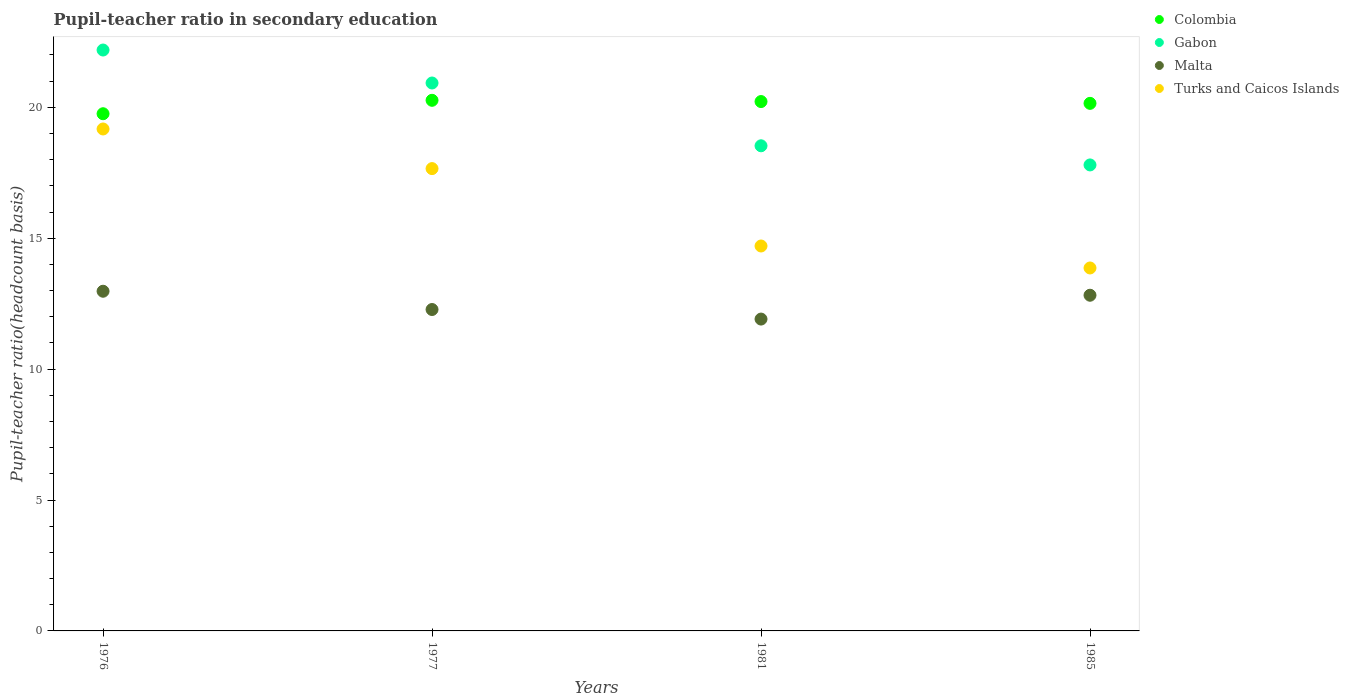How many different coloured dotlines are there?
Offer a very short reply. 4. What is the pupil-teacher ratio in secondary education in Malta in 1985?
Offer a very short reply. 12.82. Across all years, what is the maximum pupil-teacher ratio in secondary education in Turks and Caicos Islands?
Provide a short and direct response. 19.17. Across all years, what is the minimum pupil-teacher ratio in secondary education in Turks and Caicos Islands?
Your answer should be very brief. 13.86. In which year was the pupil-teacher ratio in secondary education in Turks and Caicos Islands maximum?
Offer a terse response. 1976. In which year was the pupil-teacher ratio in secondary education in Colombia minimum?
Keep it short and to the point. 1976. What is the total pupil-teacher ratio in secondary education in Malta in the graph?
Offer a very short reply. 49.98. What is the difference between the pupil-teacher ratio in secondary education in Turks and Caicos Islands in 1976 and that in 1981?
Your answer should be compact. 4.47. What is the difference between the pupil-teacher ratio in secondary education in Gabon in 1976 and the pupil-teacher ratio in secondary education in Malta in 1977?
Provide a succinct answer. 9.91. What is the average pupil-teacher ratio in secondary education in Malta per year?
Your answer should be very brief. 12.5. In the year 1976, what is the difference between the pupil-teacher ratio in secondary education in Turks and Caicos Islands and pupil-teacher ratio in secondary education in Gabon?
Your response must be concise. -3.02. What is the ratio of the pupil-teacher ratio in secondary education in Colombia in 1976 to that in 1985?
Your answer should be compact. 0.98. What is the difference between the highest and the second highest pupil-teacher ratio in secondary education in Gabon?
Make the answer very short. 1.26. What is the difference between the highest and the lowest pupil-teacher ratio in secondary education in Malta?
Your response must be concise. 1.06. In how many years, is the pupil-teacher ratio in secondary education in Turks and Caicos Islands greater than the average pupil-teacher ratio in secondary education in Turks and Caicos Islands taken over all years?
Offer a terse response. 2. Is the sum of the pupil-teacher ratio in secondary education in Malta in 1976 and 1981 greater than the maximum pupil-teacher ratio in secondary education in Turks and Caicos Islands across all years?
Offer a very short reply. Yes. Is it the case that in every year, the sum of the pupil-teacher ratio in secondary education in Turks and Caicos Islands and pupil-teacher ratio in secondary education in Malta  is greater than the pupil-teacher ratio in secondary education in Gabon?
Your answer should be very brief. Yes. Does the pupil-teacher ratio in secondary education in Turks and Caicos Islands monotonically increase over the years?
Your answer should be very brief. No. What is the difference between two consecutive major ticks on the Y-axis?
Provide a succinct answer. 5. Are the values on the major ticks of Y-axis written in scientific E-notation?
Provide a succinct answer. No. Does the graph contain any zero values?
Offer a terse response. No. Does the graph contain grids?
Offer a very short reply. No. Where does the legend appear in the graph?
Provide a short and direct response. Top right. How many legend labels are there?
Make the answer very short. 4. What is the title of the graph?
Keep it short and to the point. Pupil-teacher ratio in secondary education. What is the label or title of the X-axis?
Provide a short and direct response. Years. What is the label or title of the Y-axis?
Ensure brevity in your answer.  Pupil-teacher ratio(headcount basis). What is the Pupil-teacher ratio(headcount basis) of Colombia in 1976?
Your response must be concise. 19.75. What is the Pupil-teacher ratio(headcount basis) of Gabon in 1976?
Make the answer very short. 22.19. What is the Pupil-teacher ratio(headcount basis) of Malta in 1976?
Offer a very short reply. 12.97. What is the Pupil-teacher ratio(headcount basis) in Turks and Caicos Islands in 1976?
Keep it short and to the point. 19.17. What is the Pupil-teacher ratio(headcount basis) of Colombia in 1977?
Give a very brief answer. 20.27. What is the Pupil-teacher ratio(headcount basis) in Gabon in 1977?
Offer a very short reply. 20.93. What is the Pupil-teacher ratio(headcount basis) of Malta in 1977?
Your response must be concise. 12.28. What is the Pupil-teacher ratio(headcount basis) in Turks and Caicos Islands in 1977?
Your answer should be very brief. 17.66. What is the Pupil-teacher ratio(headcount basis) of Colombia in 1981?
Your response must be concise. 20.22. What is the Pupil-teacher ratio(headcount basis) of Gabon in 1981?
Keep it short and to the point. 18.53. What is the Pupil-teacher ratio(headcount basis) in Malta in 1981?
Your answer should be compact. 11.91. What is the Pupil-teacher ratio(headcount basis) in Turks and Caicos Islands in 1981?
Offer a very short reply. 14.7. What is the Pupil-teacher ratio(headcount basis) in Colombia in 1985?
Your answer should be compact. 20.15. What is the Pupil-teacher ratio(headcount basis) in Gabon in 1985?
Keep it short and to the point. 17.8. What is the Pupil-teacher ratio(headcount basis) of Malta in 1985?
Provide a short and direct response. 12.82. What is the Pupil-teacher ratio(headcount basis) of Turks and Caicos Islands in 1985?
Your answer should be very brief. 13.86. Across all years, what is the maximum Pupil-teacher ratio(headcount basis) in Colombia?
Your response must be concise. 20.27. Across all years, what is the maximum Pupil-teacher ratio(headcount basis) in Gabon?
Ensure brevity in your answer.  22.19. Across all years, what is the maximum Pupil-teacher ratio(headcount basis) of Malta?
Give a very brief answer. 12.97. Across all years, what is the maximum Pupil-teacher ratio(headcount basis) in Turks and Caicos Islands?
Offer a very short reply. 19.17. Across all years, what is the minimum Pupil-teacher ratio(headcount basis) of Colombia?
Your response must be concise. 19.75. Across all years, what is the minimum Pupil-teacher ratio(headcount basis) of Gabon?
Give a very brief answer. 17.8. Across all years, what is the minimum Pupil-teacher ratio(headcount basis) of Malta?
Offer a terse response. 11.91. Across all years, what is the minimum Pupil-teacher ratio(headcount basis) of Turks and Caicos Islands?
Your answer should be compact. 13.86. What is the total Pupil-teacher ratio(headcount basis) of Colombia in the graph?
Your answer should be very brief. 80.39. What is the total Pupil-teacher ratio(headcount basis) of Gabon in the graph?
Keep it short and to the point. 79.44. What is the total Pupil-teacher ratio(headcount basis) of Malta in the graph?
Offer a very short reply. 49.98. What is the total Pupil-teacher ratio(headcount basis) of Turks and Caicos Islands in the graph?
Give a very brief answer. 65.39. What is the difference between the Pupil-teacher ratio(headcount basis) in Colombia in 1976 and that in 1977?
Ensure brevity in your answer.  -0.51. What is the difference between the Pupil-teacher ratio(headcount basis) in Gabon in 1976 and that in 1977?
Offer a very short reply. 1.26. What is the difference between the Pupil-teacher ratio(headcount basis) of Malta in 1976 and that in 1977?
Provide a short and direct response. 0.7. What is the difference between the Pupil-teacher ratio(headcount basis) of Turks and Caicos Islands in 1976 and that in 1977?
Your answer should be very brief. 1.51. What is the difference between the Pupil-teacher ratio(headcount basis) in Colombia in 1976 and that in 1981?
Your answer should be compact. -0.47. What is the difference between the Pupil-teacher ratio(headcount basis) of Gabon in 1976 and that in 1981?
Provide a succinct answer. 3.66. What is the difference between the Pupil-teacher ratio(headcount basis) of Malta in 1976 and that in 1981?
Your answer should be compact. 1.06. What is the difference between the Pupil-teacher ratio(headcount basis) of Turks and Caicos Islands in 1976 and that in 1981?
Make the answer very short. 4.47. What is the difference between the Pupil-teacher ratio(headcount basis) of Colombia in 1976 and that in 1985?
Your answer should be compact. -0.4. What is the difference between the Pupil-teacher ratio(headcount basis) of Gabon in 1976 and that in 1985?
Give a very brief answer. 4.39. What is the difference between the Pupil-teacher ratio(headcount basis) of Malta in 1976 and that in 1985?
Your answer should be compact. 0.15. What is the difference between the Pupil-teacher ratio(headcount basis) in Turks and Caicos Islands in 1976 and that in 1985?
Offer a terse response. 5.31. What is the difference between the Pupil-teacher ratio(headcount basis) of Colombia in 1977 and that in 1981?
Your answer should be compact. 0.05. What is the difference between the Pupil-teacher ratio(headcount basis) of Gabon in 1977 and that in 1981?
Give a very brief answer. 2.4. What is the difference between the Pupil-teacher ratio(headcount basis) in Malta in 1977 and that in 1981?
Offer a terse response. 0.37. What is the difference between the Pupil-teacher ratio(headcount basis) of Turks and Caicos Islands in 1977 and that in 1981?
Give a very brief answer. 2.96. What is the difference between the Pupil-teacher ratio(headcount basis) in Colombia in 1977 and that in 1985?
Offer a terse response. 0.12. What is the difference between the Pupil-teacher ratio(headcount basis) in Gabon in 1977 and that in 1985?
Provide a succinct answer. 3.13. What is the difference between the Pupil-teacher ratio(headcount basis) of Malta in 1977 and that in 1985?
Offer a terse response. -0.55. What is the difference between the Pupil-teacher ratio(headcount basis) in Turks and Caicos Islands in 1977 and that in 1985?
Give a very brief answer. 3.8. What is the difference between the Pupil-teacher ratio(headcount basis) of Colombia in 1981 and that in 1985?
Keep it short and to the point. 0.07. What is the difference between the Pupil-teacher ratio(headcount basis) in Gabon in 1981 and that in 1985?
Your answer should be very brief. 0.73. What is the difference between the Pupil-teacher ratio(headcount basis) in Malta in 1981 and that in 1985?
Keep it short and to the point. -0.91. What is the difference between the Pupil-teacher ratio(headcount basis) of Turks and Caicos Islands in 1981 and that in 1985?
Your response must be concise. 0.84. What is the difference between the Pupil-teacher ratio(headcount basis) in Colombia in 1976 and the Pupil-teacher ratio(headcount basis) in Gabon in 1977?
Your response must be concise. -1.17. What is the difference between the Pupil-teacher ratio(headcount basis) of Colombia in 1976 and the Pupil-teacher ratio(headcount basis) of Malta in 1977?
Offer a terse response. 7.48. What is the difference between the Pupil-teacher ratio(headcount basis) in Colombia in 1976 and the Pupil-teacher ratio(headcount basis) in Turks and Caicos Islands in 1977?
Offer a very short reply. 2.1. What is the difference between the Pupil-teacher ratio(headcount basis) in Gabon in 1976 and the Pupil-teacher ratio(headcount basis) in Malta in 1977?
Your response must be concise. 9.91. What is the difference between the Pupil-teacher ratio(headcount basis) of Gabon in 1976 and the Pupil-teacher ratio(headcount basis) of Turks and Caicos Islands in 1977?
Ensure brevity in your answer.  4.53. What is the difference between the Pupil-teacher ratio(headcount basis) of Malta in 1976 and the Pupil-teacher ratio(headcount basis) of Turks and Caicos Islands in 1977?
Offer a terse response. -4.68. What is the difference between the Pupil-teacher ratio(headcount basis) in Colombia in 1976 and the Pupil-teacher ratio(headcount basis) in Gabon in 1981?
Make the answer very short. 1.22. What is the difference between the Pupil-teacher ratio(headcount basis) in Colombia in 1976 and the Pupil-teacher ratio(headcount basis) in Malta in 1981?
Your answer should be compact. 7.84. What is the difference between the Pupil-teacher ratio(headcount basis) in Colombia in 1976 and the Pupil-teacher ratio(headcount basis) in Turks and Caicos Islands in 1981?
Provide a short and direct response. 5.05. What is the difference between the Pupil-teacher ratio(headcount basis) in Gabon in 1976 and the Pupil-teacher ratio(headcount basis) in Malta in 1981?
Keep it short and to the point. 10.28. What is the difference between the Pupil-teacher ratio(headcount basis) in Gabon in 1976 and the Pupil-teacher ratio(headcount basis) in Turks and Caicos Islands in 1981?
Offer a terse response. 7.48. What is the difference between the Pupil-teacher ratio(headcount basis) in Malta in 1976 and the Pupil-teacher ratio(headcount basis) in Turks and Caicos Islands in 1981?
Your response must be concise. -1.73. What is the difference between the Pupil-teacher ratio(headcount basis) in Colombia in 1976 and the Pupil-teacher ratio(headcount basis) in Gabon in 1985?
Your answer should be very brief. 1.96. What is the difference between the Pupil-teacher ratio(headcount basis) in Colombia in 1976 and the Pupil-teacher ratio(headcount basis) in Malta in 1985?
Make the answer very short. 6.93. What is the difference between the Pupil-teacher ratio(headcount basis) of Colombia in 1976 and the Pupil-teacher ratio(headcount basis) of Turks and Caicos Islands in 1985?
Offer a very short reply. 5.89. What is the difference between the Pupil-teacher ratio(headcount basis) in Gabon in 1976 and the Pupil-teacher ratio(headcount basis) in Malta in 1985?
Offer a very short reply. 9.37. What is the difference between the Pupil-teacher ratio(headcount basis) in Gabon in 1976 and the Pupil-teacher ratio(headcount basis) in Turks and Caicos Islands in 1985?
Provide a short and direct response. 8.32. What is the difference between the Pupil-teacher ratio(headcount basis) of Malta in 1976 and the Pupil-teacher ratio(headcount basis) of Turks and Caicos Islands in 1985?
Keep it short and to the point. -0.89. What is the difference between the Pupil-teacher ratio(headcount basis) in Colombia in 1977 and the Pupil-teacher ratio(headcount basis) in Gabon in 1981?
Ensure brevity in your answer.  1.74. What is the difference between the Pupil-teacher ratio(headcount basis) in Colombia in 1977 and the Pupil-teacher ratio(headcount basis) in Malta in 1981?
Offer a terse response. 8.36. What is the difference between the Pupil-teacher ratio(headcount basis) of Colombia in 1977 and the Pupil-teacher ratio(headcount basis) of Turks and Caicos Islands in 1981?
Offer a terse response. 5.56. What is the difference between the Pupil-teacher ratio(headcount basis) of Gabon in 1977 and the Pupil-teacher ratio(headcount basis) of Malta in 1981?
Provide a succinct answer. 9.02. What is the difference between the Pupil-teacher ratio(headcount basis) in Gabon in 1977 and the Pupil-teacher ratio(headcount basis) in Turks and Caicos Islands in 1981?
Keep it short and to the point. 6.23. What is the difference between the Pupil-teacher ratio(headcount basis) in Malta in 1977 and the Pupil-teacher ratio(headcount basis) in Turks and Caicos Islands in 1981?
Provide a short and direct response. -2.43. What is the difference between the Pupil-teacher ratio(headcount basis) in Colombia in 1977 and the Pupil-teacher ratio(headcount basis) in Gabon in 1985?
Make the answer very short. 2.47. What is the difference between the Pupil-teacher ratio(headcount basis) of Colombia in 1977 and the Pupil-teacher ratio(headcount basis) of Malta in 1985?
Ensure brevity in your answer.  7.45. What is the difference between the Pupil-teacher ratio(headcount basis) in Colombia in 1977 and the Pupil-teacher ratio(headcount basis) in Turks and Caicos Islands in 1985?
Your answer should be compact. 6.4. What is the difference between the Pupil-teacher ratio(headcount basis) in Gabon in 1977 and the Pupil-teacher ratio(headcount basis) in Malta in 1985?
Your response must be concise. 8.11. What is the difference between the Pupil-teacher ratio(headcount basis) of Gabon in 1977 and the Pupil-teacher ratio(headcount basis) of Turks and Caicos Islands in 1985?
Provide a succinct answer. 7.07. What is the difference between the Pupil-teacher ratio(headcount basis) in Malta in 1977 and the Pupil-teacher ratio(headcount basis) in Turks and Caicos Islands in 1985?
Offer a terse response. -1.59. What is the difference between the Pupil-teacher ratio(headcount basis) in Colombia in 1981 and the Pupil-teacher ratio(headcount basis) in Gabon in 1985?
Keep it short and to the point. 2.42. What is the difference between the Pupil-teacher ratio(headcount basis) of Colombia in 1981 and the Pupil-teacher ratio(headcount basis) of Malta in 1985?
Ensure brevity in your answer.  7.4. What is the difference between the Pupil-teacher ratio(headcount basis) in Colombia in 1981 and the Pupil-teacher ratio(headcount basis) in Turks and Caicos Islands in 1985?
Your response must be concise. 6.36. What is the difference between the Pupil-teacher ratio(headcount basis) in Gabon in 1981 and the Pupil-teacher ratio(headcount basis) in Malta in 1985?
Your answer should be compact. 5.71. What is the difference between the Pupil-teacher ratio(headcount basis) of Gabon in 1981 and the Pupil-teacher ratio(headcount basis) of Turks and Caicos Islands in 1985?
Provide a short and direct response. 4.67. What is the difference between the Pupil-teacher ratio(headcount basis) in Malta in 1981 and the Pupil-teacher ratio(headcount basis) in Turks and Caicos Islands in 1985?
Offer a very short reply. -1.95. What is the average Pupil-teacher ratio(headcount basis) of Colombia per year?
Provide a succinct answer. 20.1. What is the average Pupil-teacher ratio(headcount basis) of Gabon per year?
Provide a succinct answer. 19.86. What is the average Pupil-teacher ratio(headcount basis) in Malta per year?
Offer a very short reply. 12.5. What is the average Pupil-teacher ratio(headcount basis) in Turks and Caicos Islands per year?
Provide a short and direct response. 16.35. In the year 1976, what is the difference between the Pupil-teacher ratio(headcount basis) of Colombia and Pupil-teacher ratio(headcount basis) of Gabon?
Your response must be concise. -2.43. In the year 1976, what is the difference between the Pupil-teacher ratio(headcount basis) in Colombia and Pupil-teacher ratio(headcount basis) in Malta?
Your response must be concise. 6.78. In the year 1976, what is the difference between the Pupil-teacher ratio(headcount basis) of Colombia and Pupil-teacher ratio(headcount basis) of Turks and Caicos Islands?
Make the answer very short. 0.58. In the year 1976, what is the difference between the Pupil-teacher ratio(headcount basis) in Gabon and Pupil-teacher ratio(headcount basis) in Malta?
Ensure brevity in your answer.  9.21. In the year 1976, what is the difference between the Pupil-teacher ratio(headcount basis) of Gabon and Pupil-teacher ratio(headcount basis) of Turks and Caicos Islands?
Make the answer very short. 3.02. In the year 1976, what is the difference between the Pupil-teacher ratio(headcount basis) of Malta and Pupil-teacher ratio(headcount basis) of Turks and Caicos Islands?
Your answer should be compact. -6.2. In the year 1977, what is the difference between the Pupil-teacher ratio(headcount basis) of Colombia and Pupil-teacher ratio(headcount basis) of Gabon?
Ensure brevity in your answer.  -0.66. In the year 1977, what is the difference between the Pupil-teacher ratio(headcount basis) in Colombia and Pupil-teacher ratio(headcount basis) in Malta?
Your response must be concise. 7.99. In the year 1977, what is the difference between the Pupil-teacher ratio(headcount basis) of Colombia and Pupil-teacher ratio(headcount basis) of Turks and Caicos Islands?
Your response must be concise. 2.61. In the year 1977, what is the difference between the Pupil-teacher ratio(headcount basis) in Gabon and Pupil-teacher ratio(headcount basis) in Malta?
Offer a very short reply. 8.65. In the year 1977, what is the difference between the Pupil-teacher ratio(headcount basis) of Gabon and Pupil-teacher ratio(headcount basis) of Turks and Caicos Islands?
Your answer should be very brief. 3.27. In the year 1977, what is the difference between the Pupil-teacher ratio(headcount basis) of Malta and Pupil-teacher ratio(headcount basis) of Turks and Caicos Islands?
Your response must be concise. -5.38. In the year 1981, what is the difference between the Pupil-teacher ratio(headcount basis) of Colombia and Pupil-teacher ratio(headcount basis) of Gabon?
Offer a terse response. 1.69. In the year 1981, what is the difference between the Pupil-teacher ratio(headcount basis) in Colombia and Pupil-teacher ratio(headcount basis) in Malta?
Ensure brevity in your answer.  8.31. In the year 1981, what is the difference between the Pupil-teacher ratio(headcount basis) of Colombia and Pupil-teacher ratio(headcount basis) of Turks and Caicos Islands?
Ensure brevity in your answer.  5.52. In the year 1981, what is the difference between the Pupil-teacher ratio(headcount basis) of Gabon and Pupil-teacher ratio(headcount basis) of Malta?
Provide a succinct answer. 6.62. In the year 1981, what is the difference between the Pupil-teacher ratio(headcount basis) in Gabon and Pupil-teacher ratio(headcount basis) in Turks and Caicos Islands?
Your answer should be very brief. 3.83. In the year 1981, what is the difference between the Pupil-teacher ratio(headcount basis) of Malta and Pupil-teacher ratio(headcount basis) of Turks and Caicos Islands?
Offer a very short reply. -2.79. In the year 1985, what is the difference between the Pupil-teacher ratio(headcount basis) in Colombia and Pupil-teacher ratio(headcount basis) in Gabon?
Your answer should be compact. 2.35. In the year 1985, what is the difference between the Pupil-teacher ratio(headcount basis) of Colombia and Pupil-teacher ratio(headcount basis) of Malta?
Offer a very short reply. 7.33. In the year 1985, what is the difference between the Pupil-teacher ratio(headcount basis) in Colombia and Pupil-teacher ratio(headcount basis) in Turks and Caicos Islands?
Provide a short and direct response. 6.29. In the year 1985, what is the difference between the Pupil-teacher ratio(headcount basis) of Gabon and Pupil-teacher ratio(headcount basis) of Malta?
Your response must be concise. 4.98. In the year 1985, what is the difference between the Pupil-teacher ratio(headcount basis) in Gabon and Pupil-teacher ratio(headcount basis) in Turks and Caicos Islands?
Make the answer very short. 3.94. In the year 1985, what is the difference between the Pupil-teacher ratio(headcount basis) of Malta and Pupil-teacher ratio(headcount basis) of Turks and Caicos Islands?
Provide a short and direct response. -1.04. What is the ratio of the Pupil-teacher ratio(headcount basis) in Colombia in 1976 to that in 1977?
Your response must be concise. 0.97. What is the ratio of the Pupil-teacher ratio(headcount basis) of Gabon in 1976 to that in 1977?
Give a very brief answer. 1.06. What is the ratio of the Pupil-teacher ratio(headcount basis) of Malta in 1976 to that in 1977?
Provide a short and direct response. 1.06. What is the ratio of the Pupil-teacher ratio(headcount basis) of Turks and Caicos Islands in 1976 to that in 1977?
Your answer should be compact. 1.09. What is the ratio of the Pupil-teacher ratio(headcount basis) of Colombia in 1976 to that in 1981?
Offer a terse response. 0.98. What is the ratio of the Pupil-teacher ratio(headcount basis) in Gabon in 1976 to that in 1981?
Provide a short and direct response. 1.2. What is the ratio of the Pupil-teacher ratio(headcount basis) of Malta in 1976 to that in 1981?
Your response must be concise. 1.09. What is the ratio of the Pupil-teacher ratio(headcount basis) of Turks and Caicos Islands in 1976 to that in 1981?
Your response must be concise. 1.3. What is the ratio of the Pupil-teacher ratio(headcount basis) in Colombia in 1976 to that in 1985?
Ensure brevity in your answer.  0.98. What is the ratio of the Pupil-teacher ratio(headcount basis) in Gabon in 1976 to that in 1985?
Your answer should be very brief. 1.25. What is the ratio of the Pupil-teacher ratio(headcount basis) of Malta in 1976 to that in 1985?
Keep it short and to the point. 1.01. What is the ratio of the Pupil-teacher ratio(headcount basis) of Turks and Caicos Islands in 1976 to that in 1985?
Make the answer very short. 1.38. What is the ratio of the Pupil-teacher ratio(headcount basis) of Gabon in 1977 to that in 1981?
Your answer should be compact. 1.13. What is the ratio of the Pupil-teacher ratio(headcount basis) of Malta in 1977 to that in 1981?
Make the answer very short. 1.03. What is the ratio of the Pupil-teacher ratio(headcount basis) of Turks and Caicos Islands in 1977 to that in 1981?
Provide a short and direct response. 1.2. What is the ratio of the Pupil-teacher ratio(headcount basis) in Colombia in 1977 to that in 1985?
Your response must be concise. 1.01. What is the ratio of the Pupil-teacher ratio(headcount basis) of Gabon in 1977 to that in 1985?
Offer a terse response. 1.18. What is the ratio of the Pupil-teacher ratio(headcount basis) of Malta in 1977 to that in 1985?
Keep it short and to the point. 0.96. What is the ratio of the Pupil-teacher ratio(headcount basis) in Turks and Caicos Islands in 1977 to that in 1985?
Make the answer very short. 1.27. What is the ratio of the Pupil-teacher ratio(headcount basis) of Gabon in 1981 to that in 1985?
Give a very brief answer. 1.04. What is the ratio of the Pupil-teacher ratio(headcount basis) of Malta in 1981 to that in 1985?
Your answer should be compact. 0.93. What is the ratio of the Pupil-teacher ratio(headcount basis) of Turks and Caicos Islands in 1981 to that in 1985?
Ensure brevity in your answer.  1.06. What is the difference between the highest and the second highest Pupil-teacher ratio(headcount basis) in Colombia?
Your response must be concise. 0.05. What is the difference between the highest and the second highest Pupil-teacher ratio(headcount basis) in Gabon?
Provide a short and direct response. 1.26. What is the difference between the highest and the second highest Pupil-teacher ratio(headcount basis) of Malta?
Your response must be concise. 0.15. What is the difference between the highest and the second highest Pupil-teacher ratio(headcount basis) in Turks and Caicos Islands?
Offer a very short reply. 1.51. What is the difference between the highest and the lowest Pupil-teacher ratio(headcount basis) in Colombia?
Offer a very short reply. 0.51. What is the difference between the highest and the lowest Pupil-teacher ratio(headcount basis) of Gabon?
Provide a succinct answer. 4.39. What is the difference between the highest and the lowest Pupil-teacher ratio(headcount basis) of Malta?
Provide a short and direct response. 1.06. What is the difference between the highest and the lowest Pupil-teacher ratio(headcount basis) in Turks and Caicos Islands?
Offer a very short reply. 5.31. 